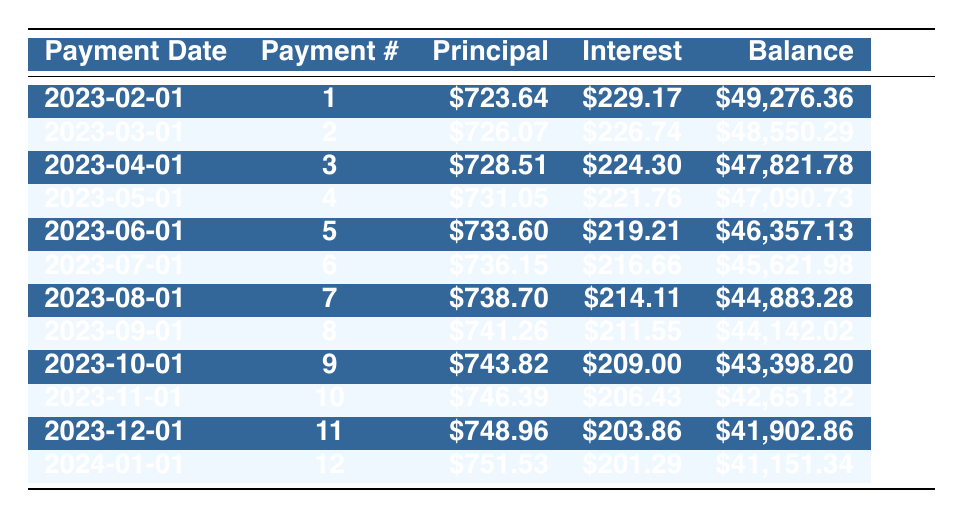What is the monthly payment amount for Daniel Thompson's loan? The monthly payment amount is explicitly listed in the table as 966.64.
Answer: 966.64 How much was the principal payment for the first month? The first row lists the principal payment for the first month (Payment #1) as 723.64.
Answer: 723.64 What is the remaining balance after the sixth payment? Referring to the sixth payment (Payment #6), the remaining balance is shown as 45621.98.
Answer: 45621.98 How much total interest will Daniel pay in the first year of repayments? To calculate the total interest for the first year, sum interest payments from Payment #1 to Payment #12: 229.17 + 226.74 + 224.30 + 221.76 + 219.21 + 216.66 + 214.11 + 211.55 + 209.00 + 206.43 + 203.86 + 201.29 = 2,631.83.
Answer: 2631.83 Does the interest payment decrease with each payment? Observing the interest payments in the table, each month the interest payment is lower than the previous month, confirming that interest payments decrease over time.
Answer: Yes 